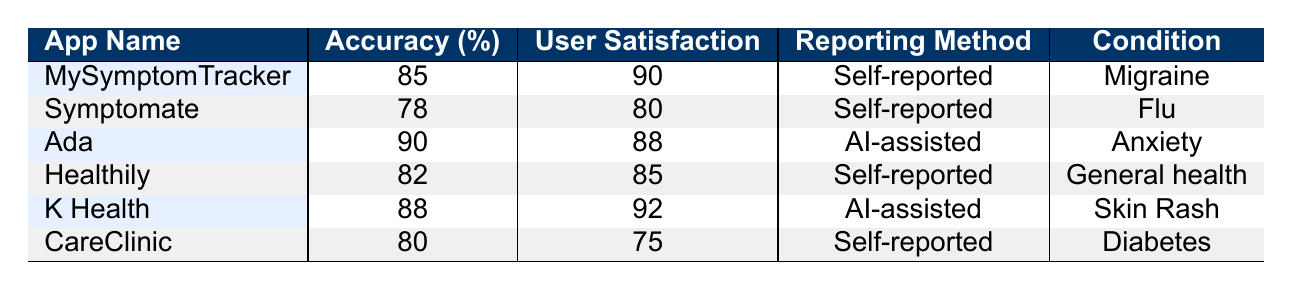What is the highest accuracy percentage among the apps listed? By reviewing the accuracy values in the table, I see that "Ada" has an accuracy of 90%, which is the highest compared to the others.
Answer: 90 Which app has the lowest user satisfaction? Looking at the user satisfaction values, "CareClinic" has the lowest score at 75%.
Answer: 75 Is there an app using AI-assisted reporting that also has user satisfaction above 90%? Checking the "User Satisfaction" column for apps with "AI-assisted" reporting, "K Health" has a score of 92%, confirming that this is true.
Answer: Yes What is the average accuracy of all the self-reported apps? The self-reported apps are "MySymptomTracker," "Symptomate," "Healthily," and "CareClinic." Their accuracies are 85, 78, 82, and 80, respectively. Adding these gives 325, and dividing by 4 yields 81.25.
Answer: 81.25 Is the reporting method of "Ada" based on self-reported data? According to the table, "Ada" uses an "AI-assisted" reporting method, which means the statement is false.
Answer: No Which condition is reported by the app with the highest user satisfaction? The app with the highest user satisfaction, "K Health," reports on "Skin Rash." This means the condition reported is skin rash.
Answer: Skin Rash If we compare the accuracy and user satisfaction of "MySymptomTracker" and "Healthily," which app has a higher accuracy and by how much? "MySymptomTracker" has an accuracy of 85%, while "Healthily" has 82%. The difference in accuracy is 3%, so "MySymptomTracker" is higher.
Answer: MySymptomTracker is higher by 3% What percentage of apps use self-reported methods? We have 4 out of 6 apps using self-reported methods. To calculate this percentage, (4/6) * 100 = 66.67%.
Answer: 66.67% 